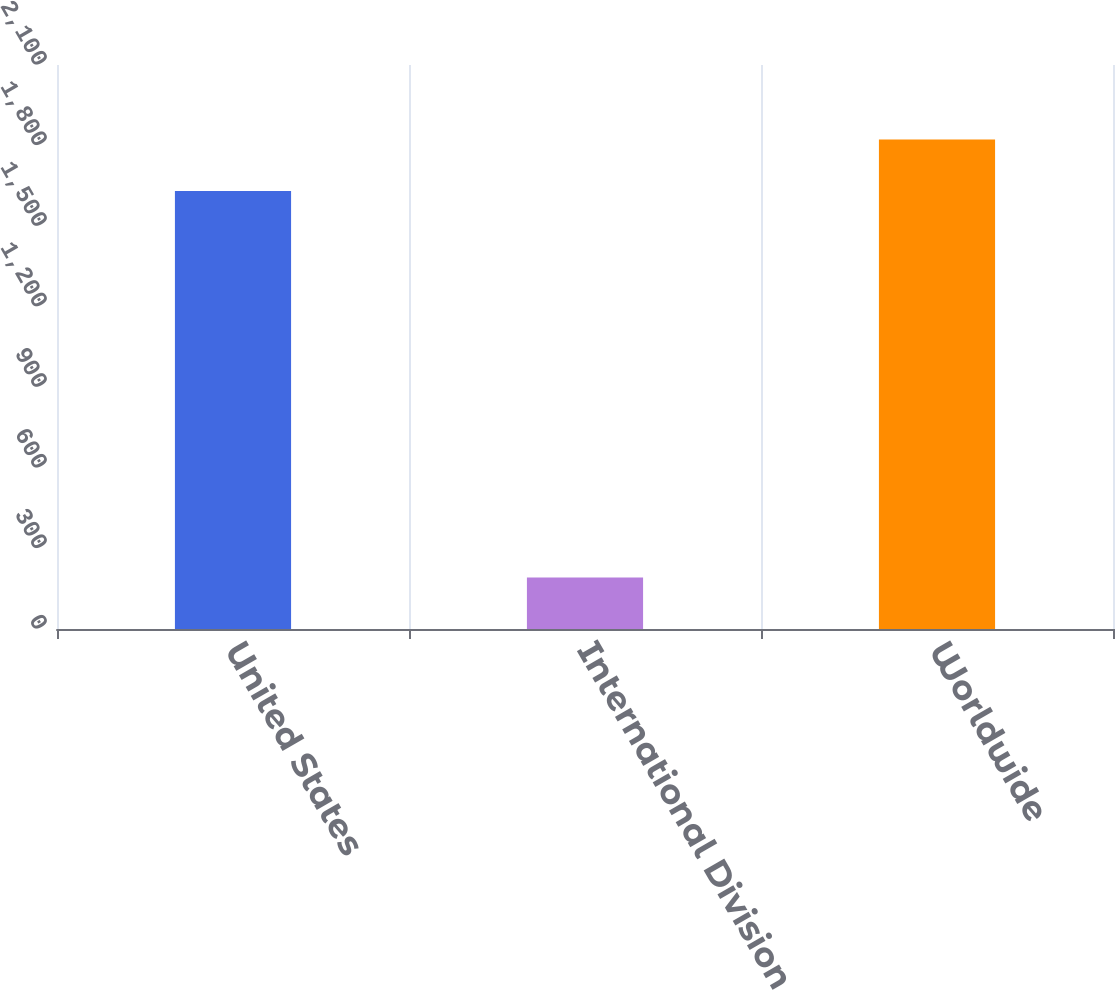Convert chart to OTSL. <chart><loc_0><loc_0><loc_500><loc_500><bar_chart><fcel>United States<fcel>International Division<fcel>Worldwide<nl><fcel>1631<fcel>192<fcel>1823<nl></chart> 